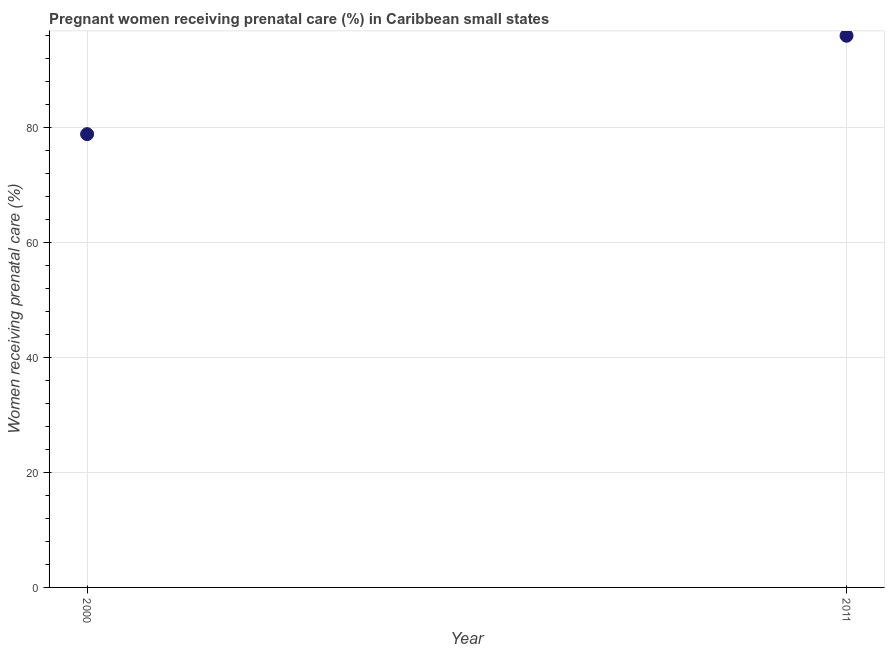What is the percentage of pregnant women receiving prenatal care in 2000?
Keep it short and to the point. 78.82. Across all years, what is the maximum percentage of pregnant women receiving prenatal care?
Give a very brief answer. 95.93. Across all years, what is the minimum percentage of pregnant women receiving prenatal care?
Offer a terse response. 78.82. What is the sum of the percentage of pregnant women receiving prenatal care?
Keep it short and to the point. 174.76. What is the difference between the percentage of pregnant women receiving prenatal care in 2000 and 2011?
Make the answer very short. -17.11. What is the average percentage of pregnant women receiving prenatal care per year?
Keep it short and to the point. 87.38. What is the median percentage of pregnant women receiving prenatal care?
Your answer should be compact. 87.38. Do a majority of the years between 2000 and 2011 (inclusive) have percentage of pregnant women receiving prenatal care greater than 64 %?
Your answer should be very brief. Yes. What is the ratio of the percentage of pregnant women receiving prenatal care in 2000 to that in 2011?
Make the answer very short. 0.82. What is the difference between two consecutive major ticks on the Y-axis?
Your response must be concise. 20. What is the title of the graph?
Keep it short and to the point. Pregnant women receiving prenatal care (%) in Caribbean small states. What is the label or title of the X-axis?
Provide a succinct answer. Year. What is the label or title of the Y-axis?
Provide a short and direct response. Women receiving prenatal care (%). What is the Women receiving prenatal care (%) in 2000?
Provide a succinct answer. 78.82. What is the Women receiving prenatal care (%) in 2011?
Ensure brevity in your answer.  95.93. What is the difference between the Women receiving prenatal care (%) in 2000 and 2011?
Give a very brief answer. -17.11. What is the ratio of the Women receiving prenatal care (%) in 2000 to that in 2011?
Your answer should be compact. 0.82. 